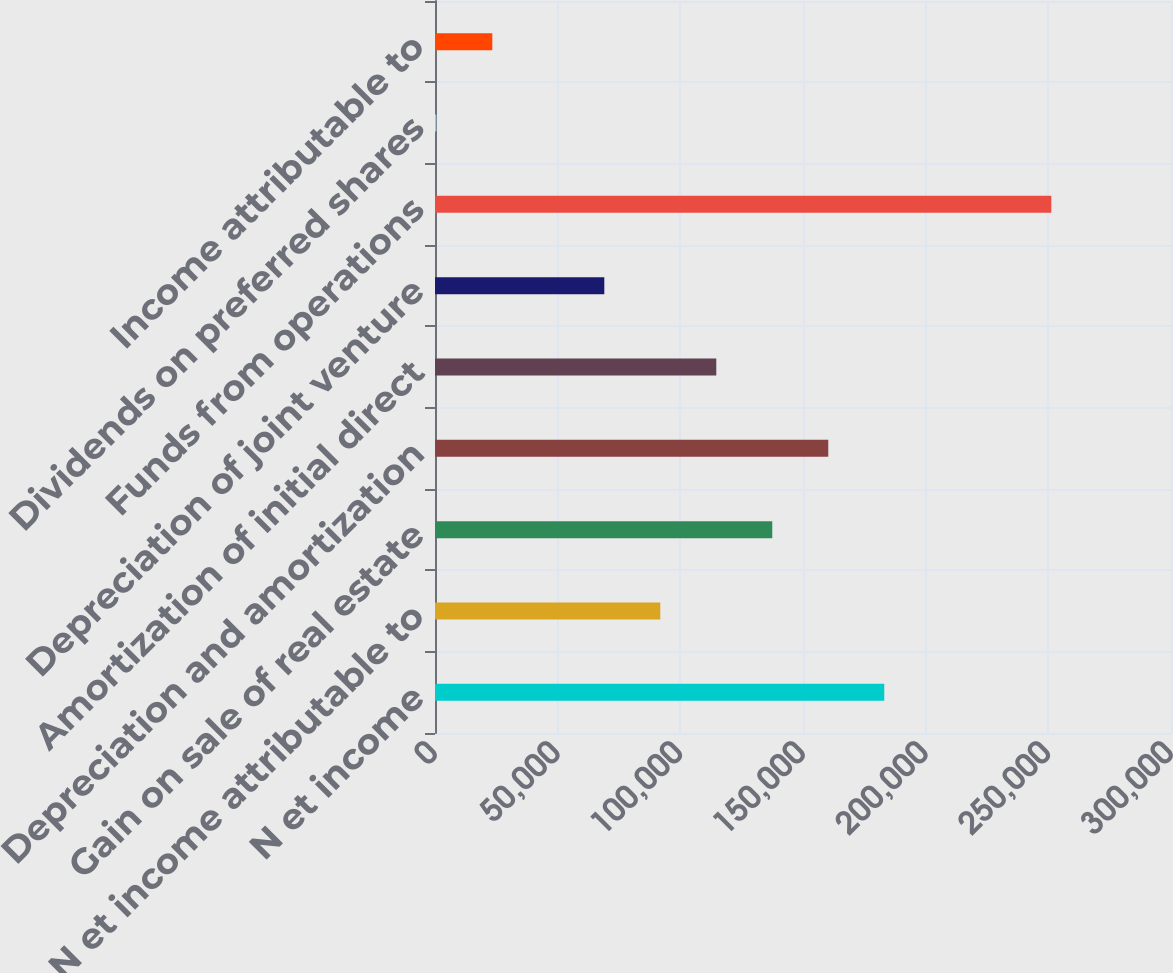Convert chart. <chart><loc_0><loc_0><loc_500><loc_500><bar_chart><fcel>N et income<fcel>N et income attributable to<fcel>Gain on sale of real estate<fcel>Depreciation and amortization<fcel>Amortization of initial direct<fcel>Depreciation of joint venture<fcel>Funds from operations<fcel>Dividends on preferred shares<fcel>Income attributable to<nl><fcel>183122<fcel>91831.4<fcel>137477<fcel>160299<fcel>114654<fcel>69008.8<fcel>251220<fcel>541<fcel>23363.6<nl></chart> 